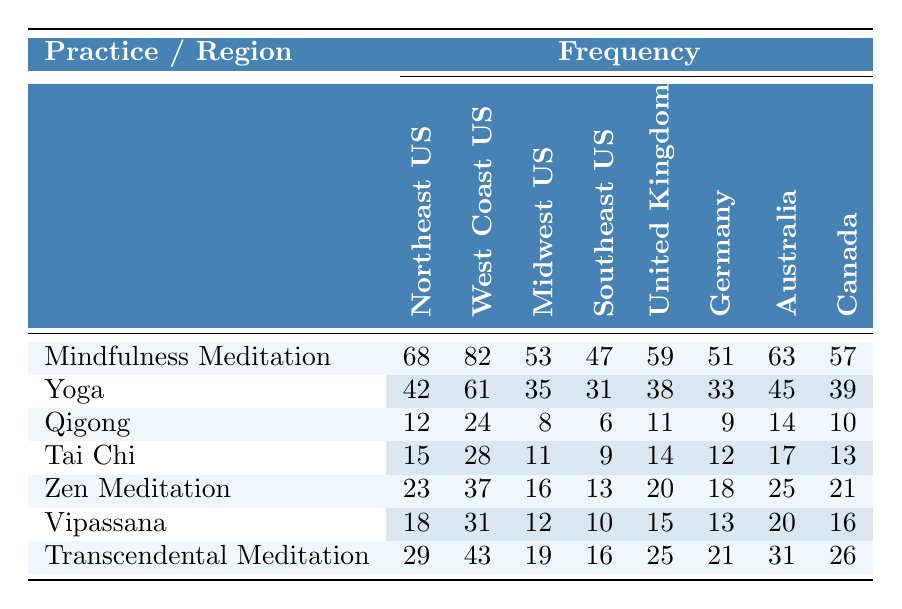What is the frequency of Mindfulness Meditation in the West Coast US? In the West Coast US column for Mindfulness Meditation, the frequency listed is 82.
Answer: 82 Which practice has the highest frequency in the Northeast US? In the Northeast US row, Mindfulness Meditation has the highest frequency at 68, compared to other practices.
Answer: Mindfulness Meditation What is the average frequency of Tai Chi across all regions? The frequencies for Tai Chi are 15, 28, 11, 9, 14, 12, 17, and 13 across the regions. Adding these gives 15+28+11+9+14+12+17+13 = 119 and dividing by 8 gives 14.875, which can be rounded to 15.
Answer: 15 Is there any practice that has a frequency of 30 or more in the Southeast US? Reviewing the Southeast US row shows the frequencies for practices: 47, 31, 6, 9, 13, 10, and 16. The only practice that meets the criteria is Mindfulness Meditation (47) and Yoga (31). Therefore, there are practices fulfilling this condition.
Answer: Yes What is the total frequency of Yoga across all regions? The frequencies for Yoga are: 42 (Northeast US), 61 (West Coast US), 35 (Midwest US), 31 (Southeast US), 38 (United Kingdom), 33 (Germany), 45 (Australia), and 39 (Canada). Summing these: 42+61+35+31+38+33+45+39 = 384.
Answer: 384 Which region has the lowest frequency for Qigong? By examining the Qigong frequencies, the Midwest US has the lowest frequency at 8, compared to others: 12, 24, 6, 11, 9, 14, and 10 in the other regions.
Answer: Midwest US How does the frequency of Transcendental Meditation in Australia compare to that in the Northeast US? In Australia, Transcendental Meditation has a frequency of 31, whereas in the Northeast US, it is 29. Thus, Australia has a higher frequency by 2.
Answer: Australia has a higher frequency by 2 